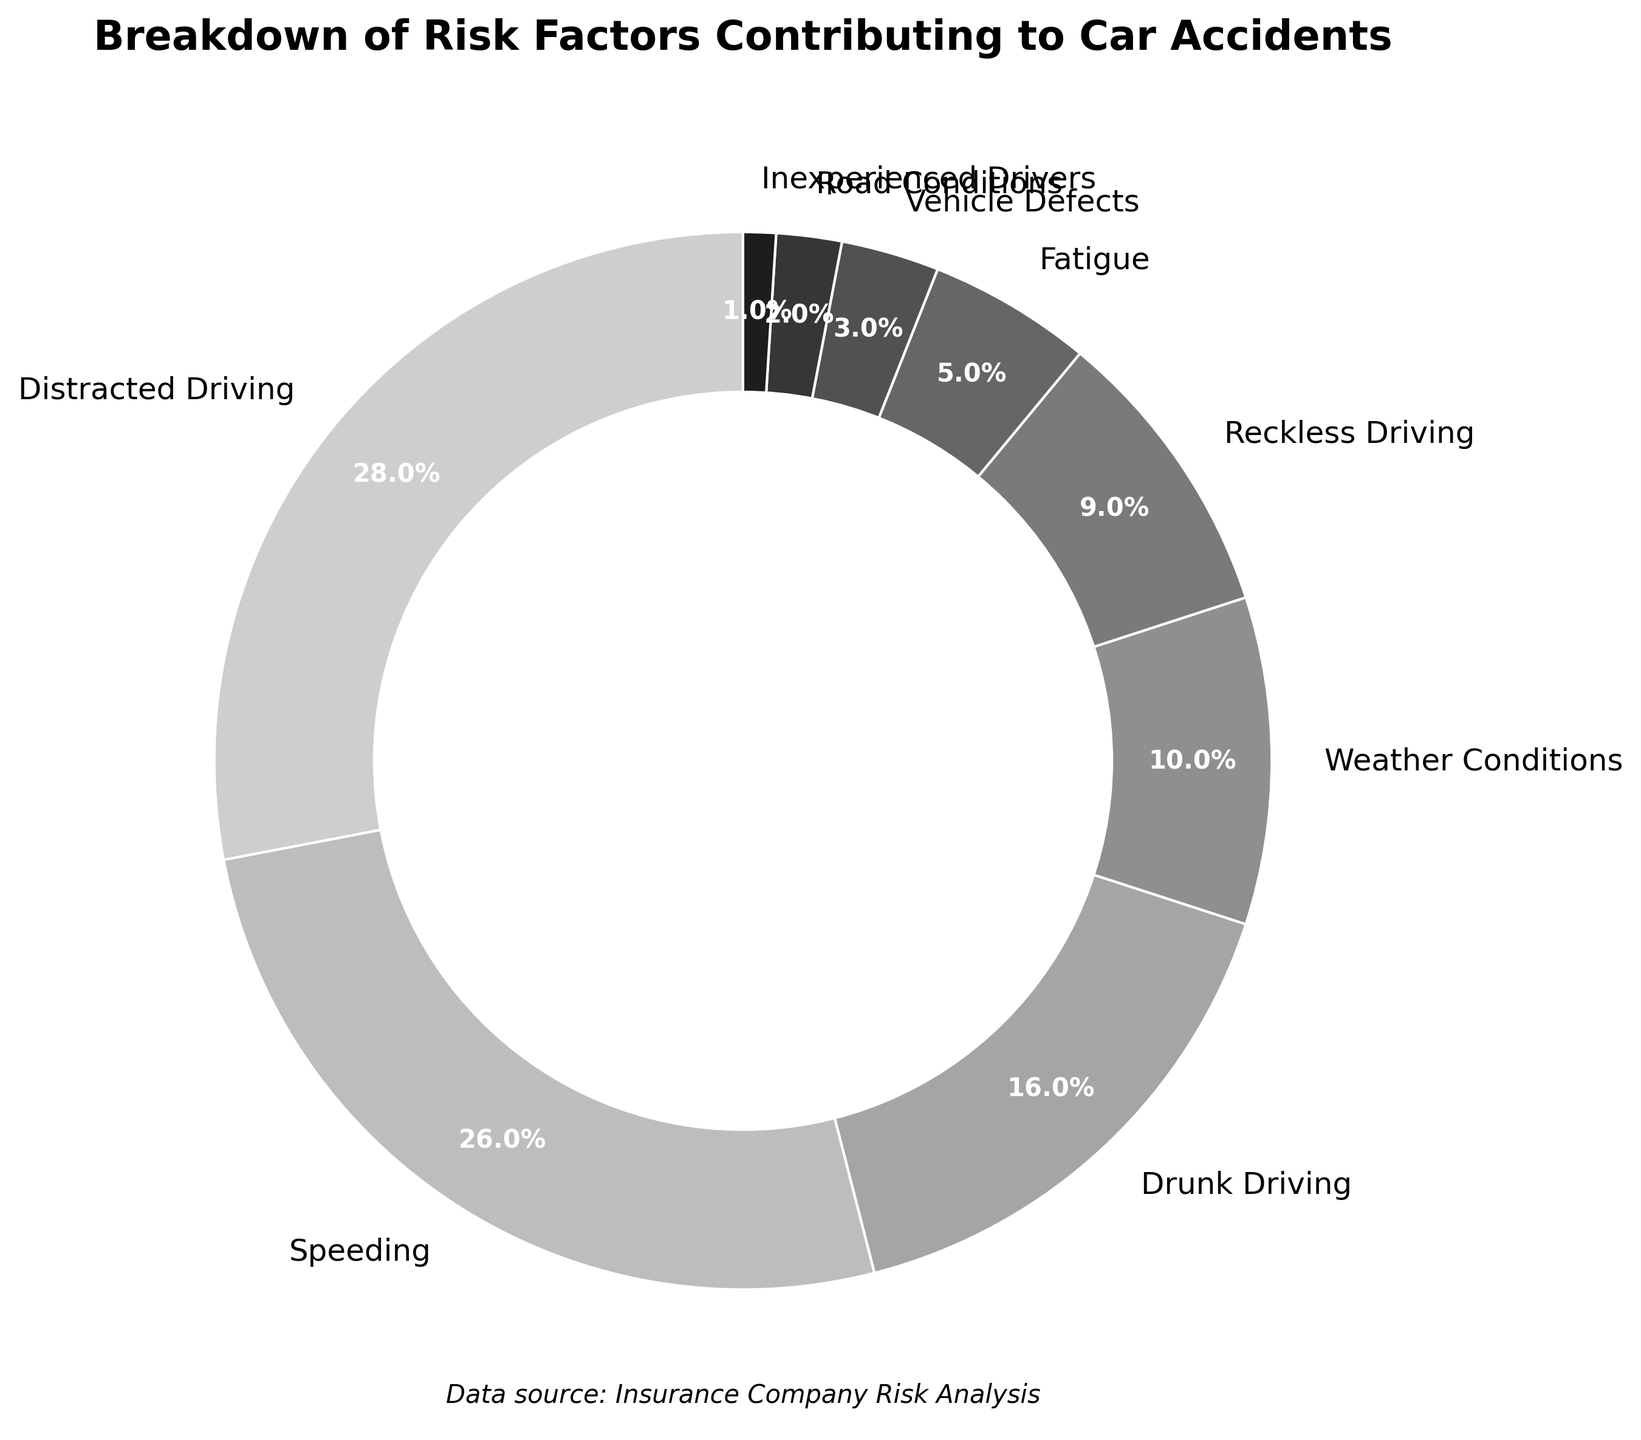Which risk factor contributes the most to car accidents? The largest segment in the pie chart represents "Distracted Driving," which has a percentage of 28%. Therefore, this factor contributes the most to car accidents.
Answer: Distracted Driving Which two risk factors have the closest percentages? By observing the pie chart, "Speeding" and "Drunk Driving" have relatively close percentages, with 26% and 16%, respectively.
Answer: Speeding and Drunk Driving What is the combined percentage of "Weather Conditions" and "Reckless Driving"? From the pie chart, "Weather Conditions" has 10% and "Reckless Driving" has 9%. Adding these percentages gives 10% + 9% = 19%.
Answer: 19% Which risk factor contributes less than 5% to car accidents? The pie chart shows several segments, but "Vehicle Defects" (3%), "Road Conditions" (2%), and "Inexperienced Drivers" (1%) all contribute less than 5%.
Answer: Vehicle Defects, Road Conditions, Inexperienced Drivers How does the percentage of "Fatigue" compare to "Reckless Driving"? By observing the pie chart, "Fatigue" has a percentage of 5% while "Reckless Driving" has 9%. Therefore, "Fatigue" contributes less to car accidents compared to "Reckless Driving".
Answer: Fatigue contributes less What is the total percentage for the three least contributing risk factors? The pie chart indicates that "Vehicle Defects" (3%), "Road Conditions" (2%), and "Inexperienced Drivers" (1%) are the three least contributing factors. Summing these gives 3% + 2% + 1% = 6%.
Answer: 6% What percentage does "Speeding" and "Distracted Driving" together account for? The "Speeding" segment is 26% and "Distracted Driving" is 28%. Adding them together: 26% + 28% = 54%.
Answer: 54% Is "Drunk Driving" more or less significant than "Weather Conditions" in contributing to car accidents? The pie chart shows "Drunk Driving" at 16% and "Weather Conditions" at 10%. Therefore, "Drunk Driving" is more significant.
Answer: More significant What is the average percentage of "Speeding" and "Fatigue"? "Speeding" has 26% and "Fatigue" has 5%. The average calculation is: (26% + 5%) / 2 = 15.5%.
Answer: 15.5% If we combine "Reckless Driving" and "Fatigue," would their total still be less than "Speeding"? Reckless Driving has 9% and Fatigue has 5%. Combined, they account for 9% + 5% = 14%. "Speeding" alone is 26%, which is greater than 14%.
Answer: Yes 